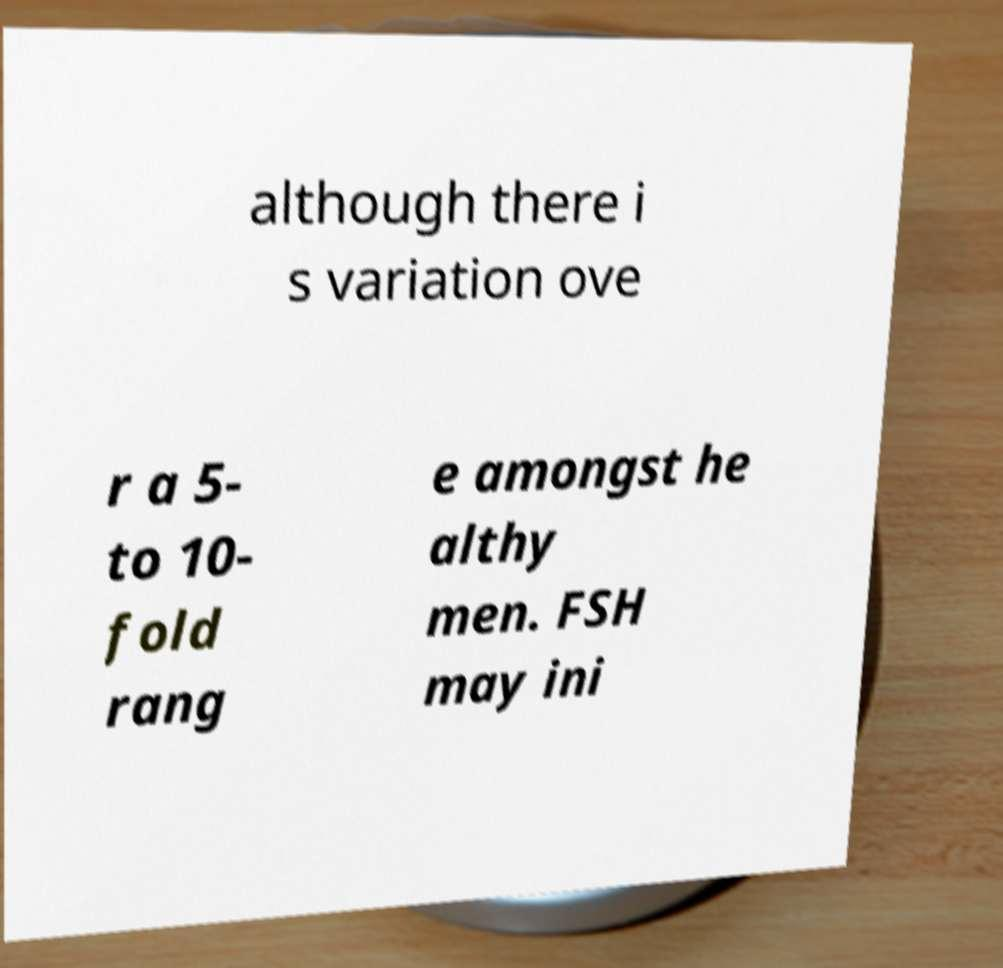Please read and relay the text visible in this image. What does it say? although there i s variation ove r a 5- to 10- fold rang e amongst he althy men. FSH may ini 